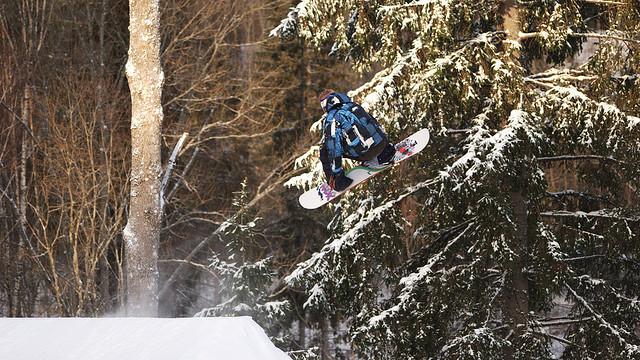Is this an Olympic sport?
Write a very short answer. Yes. Is this person skiing?
Be succinct. No. What is on the trees?
Give a very brief answer. Snow. 